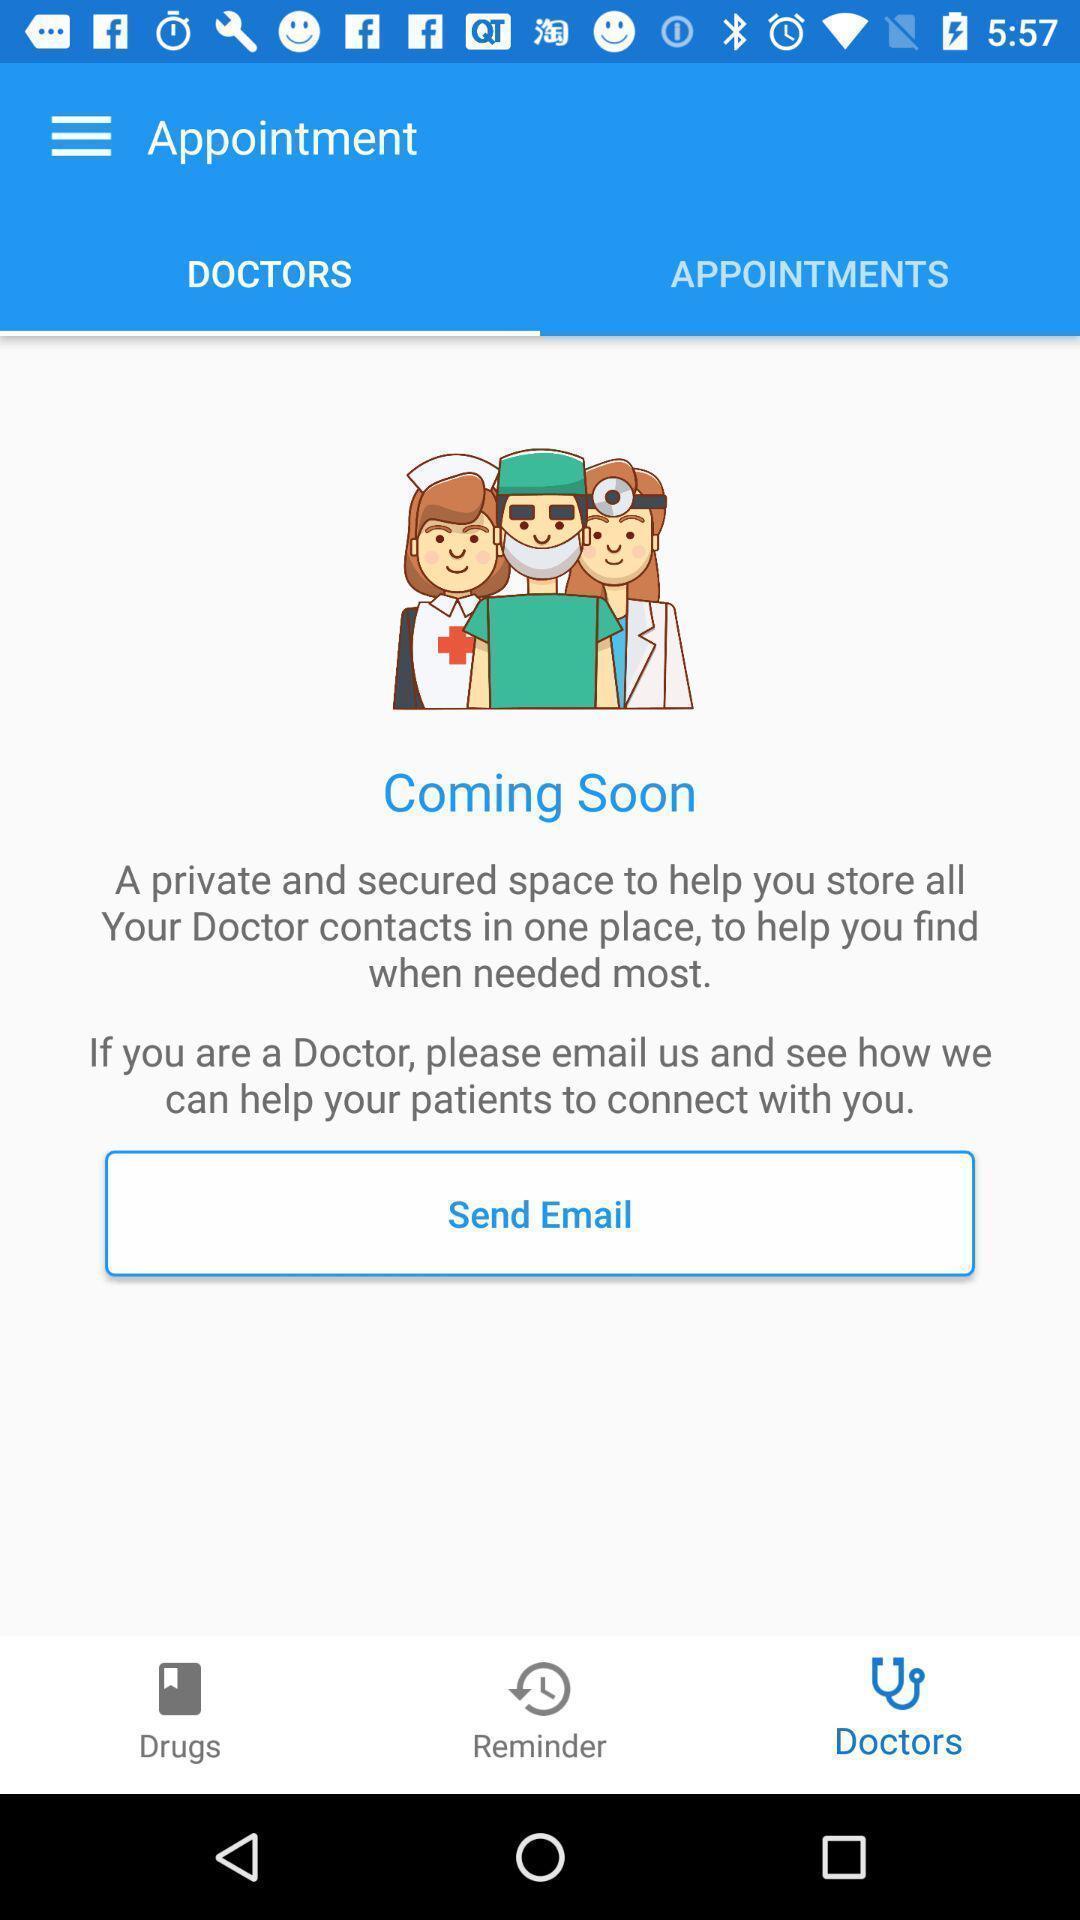Describe the visual elements of this screenshot. Screen shows appointment page of doctor. 